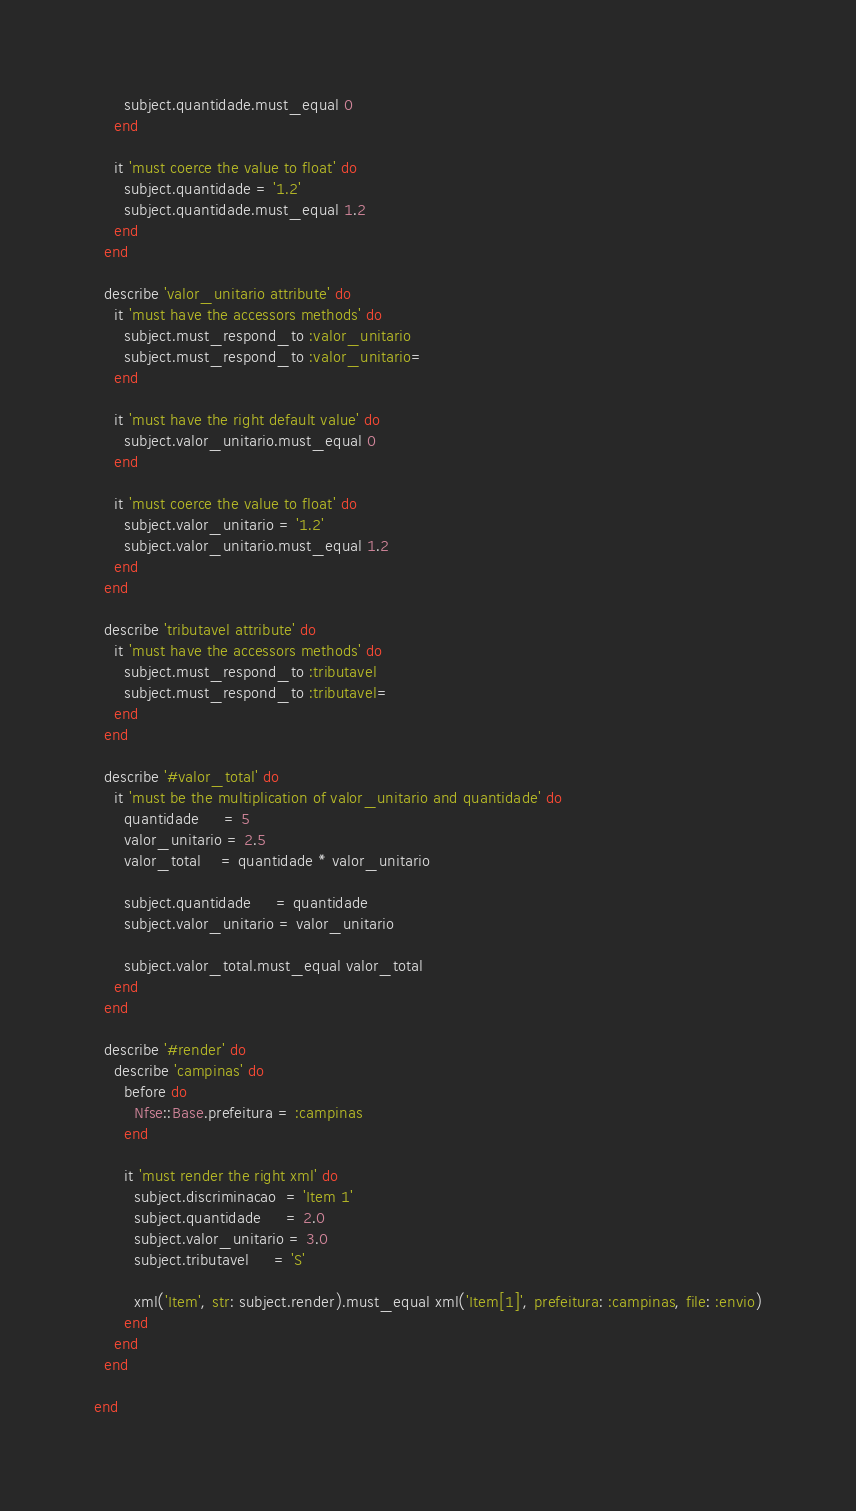Convert code to text. <code><loc_0><loc_0><loc_500><loc_500><_Ruby_>      subject.quantidade.must_equal 0
    end

    it 'must coerce the value to float' do
      subject.quantidade = '1.2'
      subject.quantidade.must_equal 1.2
    end
  end

  describe 'valor_unitario attribute' do
    it 'must have the accessors methods' do
      subject.must_respond_to :valor_unitario
      subject.must_respond_to :valor_unitario=
    end

    it 'must have the right default value' do
      subject.valor_unitario.must_equal 0
    end

    it 'must coerce the value to float' do
      subject.valor_unitario = '1.2'
      subject.valor_unitario.must_equal 1.2
    end
  end

  describe 'tributavel attribute' do
    it 'must have the accessors methods' do
      subject.must_respond_to :tributavel
      subject.must_respond_to :tributavel=
    end
  end

  describe '#valor_total' do
    it 'must be the multiplication of valor_unitario and quantidade' do
      quantidade     = 5
      valor_unitario = 2.5
      valor_total    = quantidade * valor_unitario

      subject.quantidade     = quantidade
      subject.valor_unitario = valor_unitario

      subject.valor_total.must_equal valor_total
    end
  end

  describe '#render' do
    describe 'campinas' do
      before do
        Nfse::Base.prefeitura = :campinas
      end

      it 'must render the right xml' do
        subject.discriminacao  = 'Item 1'
        subject.quantidade     = 2.0
        subject.valor_unitario = 3.0
        subject.tributavel     = 'S'

        xml('Item', str: subject.render).must_equal xml('Item[1]', prefeitura: :campinas, file: :envio)
      end
    end
  end

end
</code> 